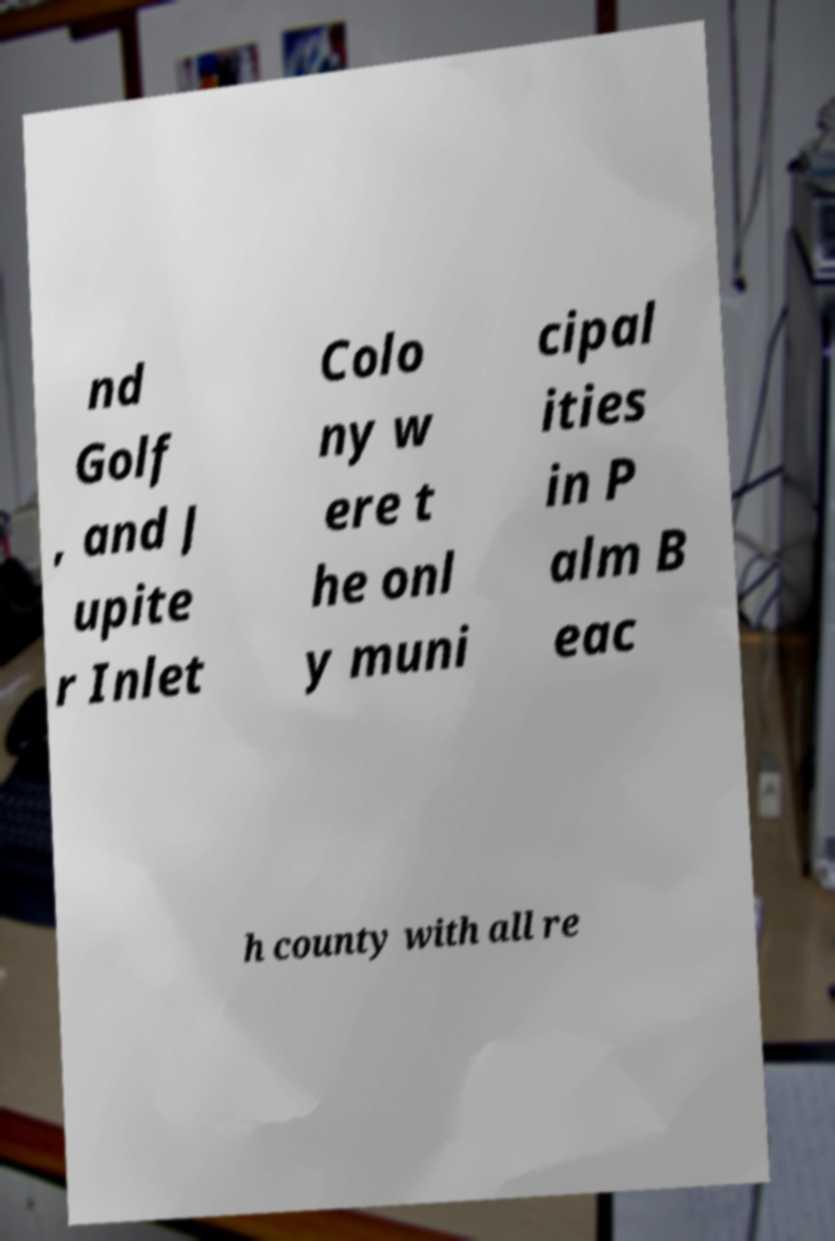Could you assist in decoding the text presented in this image and type it out clearly? nd Golf , and J upite r Inlet Colo ny w ere t he onl y muni cipal ities in P alm B eac h county with all re 